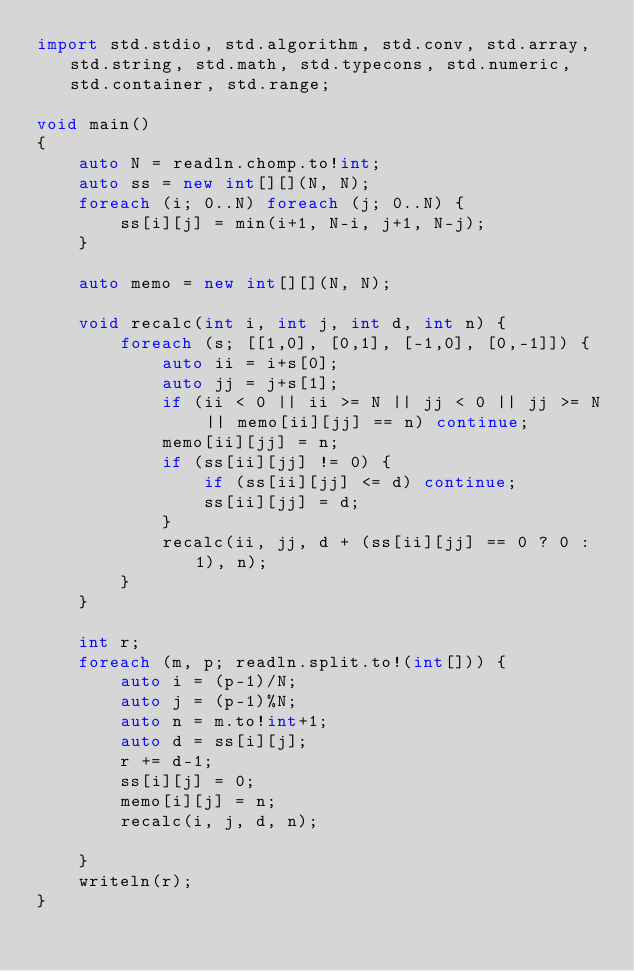Convert code to text. <code><loc_0><loc_0><loc_500><loc_500><_D_>import std.stdio, std.algorithm, std.conv, std.array, std.string, std.math, std.typecons, std.numeric, std.container, std.range;

void main()
{
    auto N = readln.chomp.to!int;
    auto ss = new int[][](N, N);
    foreach (i; 0..N) foreach (j; 0..N) {
        ss[i][j] = min(i+1, N-i, j+1, N-j);
    }

    auto memo = new int[][](N, N);

    void recalc(int i, int j, int d, int n) {
        foreach (s; [[1,0], [0,1], [-1,0], [0,-1]]) {
            auto ii = i+s[0];
            auto jj = j+s[1];
            if (ii < 0 || ii >= N || jj < 0 || jj >= N || memo[ii][jj] == n) continue;
            memo[ii][jj] = n;
            if (ss[ii][jj] != 0) {
                if (ss[ii][jj] <= d) continue;
                ss[ii][jj] = d;
            }
            recalc(ii, jj, d + (ss[ii][jj] == 0 ? 0 : 1), n);
        }
    }

    int r;
    foreach (m, p; readln.split.to!(int[])) {
        auto i = (p-1)/N;
        auto j = (p-1)%N;
        auto n = m.to!int+1;
        auto d = ss[i][j];
        r += d-1;
        ss[i][j] = 0;
        memo[i][j] = n;
        recalc(i, j, d, n);

    }
    writeln(r);
}</code> 